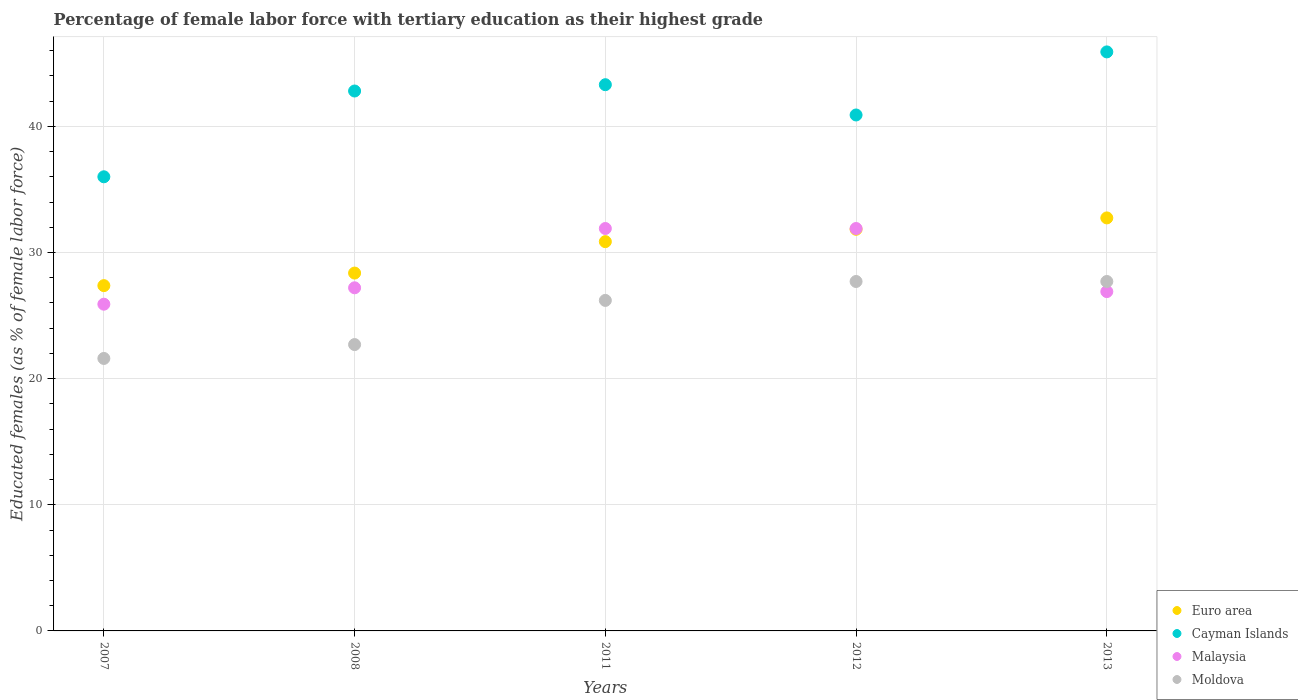How many different coloured dotlines are there?
Offer a terse response. 4. What is the percentage of female labor force with tertiary education in Euro area in 2013?
Your answer should be very brief. 32.74. Across all years, what is the maximum percentage of female labor force with tertiary education in Malaysia?
Your response must be concise. 31.9. Across all years, what is the minimum percentage of female labor force with tertiary education in Euro area?
Your response must be concise. 27.37. In which year was the percentage of female labor force with tertiary education in Euro area minimum?
Offer a terse response. 2007. What is the total percentage of female labor force with tertiary education in Moldova in the graph?
Provide a succinct answer. 125.9. What is the difference between the percentage of female labor force with tertiary education in Euro area in 2008 and that in 2013?
Your answer should be very brief. -4.37. What is the difference between the percentage of female labor force with tertiary education in Malaysia in 2011 and the percentage of female labor force with tertiary education in Euro area in 2008?
Offer a terse response. 3.53. What is the average percentage of female labor force with tertiary education in Cayman Islands per year?
Offer a terse response. 41.78. In the year 2013, what is the difference between the percentage of female labor force with tertiary education in Euro area and percentage of female labor force with tertiary education in Malaysia?
Keep it short and to the point. 5.84. What is the ratio of the percentage of female labor force with tertiary education in Moldova in 2007 to that in 2012?
Ensure brevity in your answer.  0.78. Is the difference between the percentage of female labor force with tertiary education in Euro area in 2007 and 2011 greater than the difference between the percentage of female labor force with tertiary education in Malaysia in 2007 and 2011?
Provide a short and direct response. Yes. What is the difference between the highest and the second highest percentage of female labor force with tertiary education in Moldova?
Offer a very short reply. 0. What is the difference between the highest and the lowest percentage of female labor force with tertiary education in Moldova?
Offer a very short reply. 6.1. Is it the case that in every year, the sum of the percentage of female labor force with tertiary education in Euro area and percentage of female labor force with tertiary education in Malaysia  is greater than the sum of percentage of female labor force with tertiary education in Cayman Islands and percentage of female labor force with tertiary education in Moldova?
Give a very brief answer. No. Is it the case that in every year, the sum of the percentage of female labor force with tertiary education in Malaysia and percentage of female labor force with tertiary education in Moldova  is greater than the percentage of female labor force with tertiary education in Cayman Islands?
Offer a terse response. Yes. Is the percentage of female labor force with tertiary education in Cayman Islands strictly greater than the percentage of female labor force with tertiary education in Moldova over the years?
Your response must be concise. Yes. Is the percentage of female labor force with tertiary education in Moldova strictly less than the percentage of female labor force with tertiary education in Cayman Islands over the years?
Give a very brief answer. Yes. How many years are there in the graph?
Your response must be concise. 5. What is the difference between two consecutive major ticks on the Y-axis?
Offer a terse response. 10. Are the values on the major ticks of Y-axis written in scientific E-notation?
Give a very brief answer. No. Does the graph contain grids?
Provide a succinct answer. Yes. How many legend labels are there?
Offer a very short reply. 4. How are the legend labels stacked?
Keep it short and to the point. Vertical. What is the title of the graph?
Keep it short and to the point. Percentage of female labor force with tertiary education as their highest grade. Does "Iran" appear as one of the legend labels in the graph?
Give a very brief answer. No. What is the label or title of the X-axis?
Ensure brevity in your answer.  Years. What is the label or title of the Y-axis?
Offer a very short reply. Educated females (as % of female labor force). What is the Educated females (as % of female labor force) of Euro area in 2007?
Ensure brevity in your answer.  27.37. What is the Educated females (as % of female labor force) of Cayman Islands in 2007?
Your response must be concise. 36. What is the Educated females (as % of female labor force) in Malaysia in 2007?
Offer a very short reply. 25.9. What is the Educated females (as % of female labor force) in Moldova in 2007?
Keep it short and to the point. 21.6. What is the Educated females (as % of female labor force) in Euro area in 2008?
Your answer should be very brief. 28.37. What is the Educated females (as % of female labor force) in Cayman Islands in 2008?
Offer a terse response. 42.8. What is the Educated females (as % of female labor force) of Malaysia in 2008?
Provide a short and direct response. 27.2. What is the Educated females (as % of female labor force) in Moldova in 2008?
Make the answer very short. 22.7. What is the Educated females (as % of female labor force) of Euro area in 2011?
Give a very brief answer. 30.86. What is the Educated females (as % of female labor force) in Cayman Islands in 2011?
Ensure brevity in your answer.  43.3. What is the Educated females (as % of female labor force) of Malaysia in 2011?
Give a very brief answer. 31.9. What is the Educated females (as % of female labor force) in Moldova in 2011?
Keep it short and to the point. 26.2. What is the Educated females (as % of female labor force) in Euro area in 2012?
Your answer should be compact. 31.84. What is the Educated females (as % of female labor force) in Cayman Islands in 2012?
Make the answer very short. 40.9. What is the Educated females (as % of female labor force) in Malaysia in 2012?
Offer a terse response. 31.9. What is the Educated females (as % of female labor force) of Moldova in 2012?
Provide a succinct answer. 27.7. What is the Educated females (as % of female labor force) of Euro area in 2013?
Provide a short and direct response. 32.74. What is the Educated females (as % of female labor force) in Cayman Islands in 2013?
Provide a succinct answer. 45.9. What is the Educated females (as % of female labor force) of Malaysia in 2013?
Provide a short and direct response. 26.9. What is the Educated females (as % of female labor force) in Moldova in 2013?
Ensure brevity in your answer.  27.7. Across all years, what is the maximum Educated females (as % of female labor force) in Euro area?
Offer a terse response. 32.74. Across all years, what is the maximum Educated females (as % of female labor force) in Cayman Islands?
Provide a succinct answer. 45.9. Across all years, what is the maximum Educated females (as % of female labor force) of Malaysia?
Make the answer very short. 31.9. Across all years, what is the maximum Educated females (as % of female labor force) of Moldova?
Provide a short and direct response. 27.7. Across all years, what is the minimum Educated females (as % of female labor force) in Euro area?
Your answer should be very brief. 27.37. Across all years, what is the minimum Educated females (as % of female labor force) in Cayman Islands?
Give a very brief answer. 36. Across all years, what is the minimum Educated females (as % of female labor force) in Malaysia?
Your answer should be very brief. 25.9. Across all years, what is the minimum Educated females (as % of female labor force) of Moldova?
Provide a short and direct response. 21.6. What is the total Educated females (as % of female labor force) of Euro area in the graph?
Keep it short and to the point. 151.18. What is the total Educated females (as % of female labor force) of Cayman Islands in the graph?
Keep it short and to the point. 208.9. What is the total Educated females (as % of female labor force) of Malaysia in the graph?
Give a very brief answer. 143.8. What is the total Educated females (as % of female labor force) in Moldova in the graph?
Offer a terse response. 125.9. What is the difference between the Educated females (as % of female labor force) in Euro area in 2007 and that in 2008?
Provide a succinct answer. -1. What is the difference between the Educated females (as % of female labor force) of Malaysia in 2007 and that in 2008?
Your answer should be very brief. -1.3. What is the difference between the Educated females (as % of female labor force) in Euro area in 2007 and that in 2011?
Your answer should be very brief. -3.49. What is the difference between the Educated females (as % of female labor force) in Cayman Islands in 2007 and that in 2011?
Offer a terse response. -7.3. What is the difference between the Educated females (as % of female labor force) in Euro area in 2007 and that in 2012?
Offer a very short reply. -4.47. What is the difference between the Educated females (as % of female labor force) in Malaysia in 2007 and that in 2012?
Ensure brevity in your answer.  -6. What is the difference between the Educated females (as % of female labor force) of Moldova in 2007 and that in 2012?
Keep it short and to the point. -6.1. What is the difference between the Educated females (as % of female labor force) of Euro area in 2007 and that in 2013?
Keep it short and to the point. -5.37. What is the difference between the Educated females (as % of female labor force) in Cayman Islands in 2007 and that in 2013?
Your answer should be compact. -9.9. What is the difference between the Educated females (as % of female labor force) in Malaysia in 2007 and that in 2013?
Ensure brevity in your answer.  -1. What is the difference between the Educated females (as % of female labor force) in Moldova in 2007 and that in 2013?
Give a very brief answer. -6.1. What is the difference between the Educated females (as % of female labor force) in Euro area in 2008 and that in 2011?
Offer a terse response. -2.49. What is the difference between the Educated females (as % of female labor force) of Cayman Islands in 2008 and that in 2011?
Keep it short and to the point. -0.5. What is the difference between the Educated females (as % of female labor force) in Malaysia in 2008 and that in 2011?
Provide a succinct answer. -4.7. What is the difference between the Educated females (as % of female labor force) in Euro area in 2008 and that in 2012?
Keep it short and to the point. -3.47. What is the difference between the Educated females (as % of female labor force) of Cayman Islands in 2008 and that in 2012?
Your response must be concise. 1.9. What is the difference between the Educated females (as % of female labor force) of Malaysia in 2008 and that in 2012?
Keep it short and to the point. -4.7. What is the difference between the Educated females (as % of female labor force) of Moldova in 2008 and that in 2012?
Offer a terse response. -5. What is the difference between the Educated females (as % of female labor force) in Euro area in 2008 and that in 2013?
Your answer should be compact. -4.37. What is the difference between the Educated females (as % of female labor force) of Cayman Islands in 2008 and that in 2013?
Give a very brief answer. -3.1. What is the difference between the Educated females (as % of female labor force) in Malaysia in 2008 and that in 2013?
Your answer should be very brief. 0.3. What is the difference between the Educated females (as % of female labor force) in Euro area in 2011 and that in 2012?
Make the answer very short. -0.98. What is the difference between the Educated females (as % of female labor force) in Cayman Islands in 2011 and that in 2012?
Give a very brief answer. 2.4. What is the difference between the Educated females (as % of female labor force) in Moldova in 2011 and that in 2012?
Your response must be concise. -1.5. What is the difference between the Educated females (as % of female labor force) in Euro area in 2011 and that in 2013?
Give a very brief answer. -1.88. What is the difference between the Educated females (as % of female labor force) of Cayman Islands in 2011 and that in 2013?
Your answer should be compact. -2.6. What is the difference between the Educated females (as % of female labor force) in Malaysia in 2011 and that in 2013?
Make the answer very short. 5. What is the difference between the Educated females (as % of female labor force) in Moldova in 2011 and that in 2013?
Your answer should be compact. -1.5. What is the difference between the Educated females (as % of female labor force) of Euro area in 2012 and that in 2013?
Make the answer very short. -0.9. What is the difference between the Educated females (as % of female labor force) in Malaysia in 2012 and that in 2013?
Offer a very short reply. 5. What is the difference between the Educated females (as % of female labor force) of Euro area in 2007 and the Educated females (as % of female labor force) of Cayman Islands in 2008?
Offer a terse response. -15.43. What is the difference between the Educated females (as % of female labor force) of Euro area in 2007 and the Educated females (as % of female labor force) of Malaysia in 2008?
Your response must be concise. 0.17. What is the difference between the Educated females (as % of female labor force) of Euro area in 2007 and the Educated females (as % of female labor force) of Moldova in 2008?
Offer a very short reply. 4.67. What is the difference between the Educated females (as % of female labor force) of Cayman Islands in 2007 and the Educated females (as % of female labor force) of Moldova in 2008?
Your answer should be compact. 13.3. What is the difference between the Educated females (as % of female labor force) of Euro area in 2007 and the Educated females (as % of female labor force) of Cayman Islands in 2011?
Give a very brief answer. -15.93. What is the difference between the Educated females (as % of female labor force) in Euro area in 2007 and the Educated females (as % of female labor force) in Malaysia in 2011?
Ensure brevity in your answer.  -4.53. What is the difference between the Educated females (as % of female labor force) of Euro area in 2007 and the Educated females (as % of female labor force) of Moldova in 2011?
Your response must be concise. 1.17. What is the difference between the Educated females (as % of female labor force) in Cayman Islands in 2007 and the Educated females (as % of female labor force) in Moldova in 2011?
Make the answer very short. 9.8. What is the difference between the Educated females (as % of female labor force) in Malaysia in 2007 and the Educated females (as % of female labor force) in Moldova in 2011?
Your response must be concise. -0.3. What is the difference between the Educated females (as % of female labor force) in Euro area in 2007 and the Educated females (as % of female labor force) in Cayman Islands in 2012?
Your response must be concise. -13.53. What is the difference between the Educated females (as % of female labor force) of Euro area in 2007 and the Educated females (as % of female labor force) of Malaysia in 2012?
Make the answer very short. -4.53. What is the difference between the Educated females (as % of female labor force) of Euro area in 2007 and the Educated females (as % of female labor force) of Moldova in 2012?
Make the answer very short. -0.33. What is the difference between the Educated females (as % of female labor force) in Malaysia in 2007 and the Educated females (as % of female labor force) in Moldova in 2012?
Your response must be concise. -1.8. What is the difference between the Educated females (as % of female labor force) of Euro area in 2007 and the Educated females (as % of female labor force) of Cayman Islands in 2013?
Keep it short and to the point. -18.53. What is the difference between the Educated females (as % of female labor force) of Euro area in 2007 and the Educated females (as % of female labor force) of Malaysia in 2013?
Make the answer very short. 0.47. What is the difference between the Educated females (as % of female labor force) of Euro area in 2007 and the Educated females (as % of female labor force) of Moldova in 2013?
Ensure brevity in your answer.  -0.33. What is the difference between the Educated females (as % of female labor force) in Cayman Islands in 2007 and the Educated females (as % of female labor force) in Malaysia in 2013?
Give a very brief answer. 9.1. What is the difference between the Educated females (as % of female labor force) in Euro area in 2008 and the Educated females (as % of female labor force) in Cayman Islands in 2011?
Keep it short and to the point. -14.93. What is the difference between the Educated females (as % of female labor force) in Euro area in 2008 and the Educated females (as % of female labor force) in Malaysia in 2011?
Your answer should be very brief. -3.53. What is the difference between the Educated females (as % of female labor force) in Euro area in 2008 and the Educated females (as % of female labor force) in Moldova in 2011?
Make the answer very short. 2.17. What is the difference between the Educated females (as % of female labor force) of Cayman Islands in 2008 and the Educated females (as % of female labor force) of Malaysia in 2011?
Your answer should be very brief. 10.9. What is the difference between the Educated females (as % of female labor force) of Euro area in 2008 and the Educated females (as % of female labor force) of Cayman Islands in 2012?
Provide a succinct answer. -12.53. What is the difference between the Educated females (as % of female labor force) in Euro area in 2008 and the Educated females (as % of female labor force) in Malaysia in 2012?
Offer a terse response. -3.53. What is the difference between the Educated females (as % of female labor force) in Euro area in 2008 and the Educated females (as % of female labor force) in Moldova in 2012?
Provide a short and direct response. 0.67. What is the difference between the Educated females (as % of female labor force) of Euro area in 2008 and the Educated females (as % of female labor force) of Cayman Islands in 2013?
Give a very brief answer. -17.53. What is the difference between the Educated females (as % of female labor force) of Euro area in 2008 and the Educated females (as % of female labor force) of Malaysia in 2013?
Provide a succinct answer. 1.47. What is the difference between the Educated females (as % of female labor force) in Euro area in 2008 and the Educated females (as % of female labor force) in Moldova in 2013?
Provide a short and direct response. 0.67. What is the difference between the Educated females (as % of female labor force) in Cayman Islands in 2008 and the Educated females (as % of female labor force) in Malaysia in 2013?
Give a very brief answer. 15.9. What is the difference between the Educated females (as % of female labor force) in Cayman Islands in 2008 and the Educated females (as % of female labor force) in Moldova in 2013?
Provide a short and direct response. 15.1. What is the difference between the Educated females (as % of female labor force) of Euro area in 2011 and the Educated females (as % of female labor force) of Cayman Islands in 2012?
Make the answer very short. -10.04. What is the difference between the Educated females (as % of female labor force) in Euro area in 2011 and the Educated females (as % of female labor force) in Malaysia in 2012?
Keep it short and to the point. -1.04. What is the difference between the Educated females (as % of female labor force) in Euro area in 2011 and the Educated females (as % of female labor force) in Moldova in 2012?
Give a very brief answer. 3.16. What is the difference between the Educated females (as % of female labor force) of Euro area in 2011 and the Educated females (as % of female labor force) of Cayman Islands in 2013?
Your response must be concise. -15.04. What is the difference between the Educated females (as % of female labor force) in Euro area in 2011 and the Educated females (as % of female labor force) in Malaysia in 2013?
Your answer should be compact. 3.96. What is the difference between the Educated females (as % of female labor force) of Euro area in 2011 and the Educated females (as % of female labor force) of Moldova in 2013?
Ensure brevity in your answer.  3.16. What is the difference between the Educated females (as % of female labor force) of Malaysia in 2011 and the Educated females (as % of female labor force) of Moldova in 2013?
Ensure brevity in your answer.  4.2. What is the difference between the Educated females (as % of female labor force) in Euro area in 2012 and the Educated females (as % of female labor force) in Cayman Islands in 2013?
Offer a terse response. -14.06. What is the difference between the Educated females (as % of female labor force) of Euro area in 2012 and the Educated females (as % of female labor force) of Malaysia in 2013?
Ensure brevity in your answer.  4.94. What is the difference between the Educated females (as % of female labor force) of Euro area in 2012 and the Educated females (as % of female labor force) of Moldova in 2013?
Your answer should be very brief. 4.14. What is the difference between the Educated females (as % of female labor force) of Cayman Islands in 2012 and the Educated females (as % of female labor force) of Malaysia in 2013?
Keep it short and to the point. 14. What is the difference between the Educated females (as % of female labor force) of Cayman Islands in 2012 and the Educated females (as % of female labor force) of Moldova in 2013?
Give a very brief answer. 13.2. What is the difference between the Educated females (as % of female labor force) in Malaysia in 2012 and the Educated females (as % of female labor force) in Moldova in 2013?
Provide a short and direct response. 4.2. What is the average Educated females (as % of female labor force) in Euro area per year?
Your answer should be very brief. 30.24. What is the average Educated females (as % of female labor force) in Cayman Islands per year?
Your response must be concise. 41.78. What is the average Educated females (as % of female labor force) of Malaysia per year?
Offer a terse response. 28.76. What is the average Educated females (as % of female labor force) of Moldova per year?
Your answer should be very brief. 25.18. In the year 2007, what is the difference between the Educated females (as % of female labor force) in Euro area and Educated females (as % of female labor force) in Cayman Islands?
Keep it short and to the point. -8.63. In the year 2007, what is the difference between the Educated females (as % of female labor force) of Euro area and Educated females (as % of female labor force) of Malaysia?
Give a very brief answer. 1.47. In the year 2007, what is the difference between the Educated females (as % of female labor force) of Euro area and Educated females (as % of female labor force) of Moldova?
Give a very brief answer. 5.77. In the year 2007, what is the difference between the Educated females (as % of female labor force) of Cayman Islands and Educated females (as % of female labor force) of Moldova?
Make the answer very short. 14.4. In the year 2007, what is the difference between the Educated females (as % of female labor force) in Malaysia and Educated females (as % of female labor force) in Moldova?
Make the answer very short. 4.3. In the year 2008, what is the difference between the Educated females (as % of female labor force) in Euro area and Educated females (as % of female labor force) in Cayman Islands?
Offer a terse response. -14.43. In the year 2008, what is the difference between the Educated females (as % of female labor force) of Euro area and Educated females (as % of female labor force) of Malaysia?
Offer a terse response. 1.17. In the year 2008, what is the difference between the Educated females (as % of female labor force) of Euro area and Educated females (as % of female labor force) of Moldova?
Your answer should be compact. 5.67. In the year 2008, what is the difference between the Educated females (as % of female labor force) in Cayman Islands and Educated females (as % of female labor force) in Malaysia?
Your answer should be very brief. 15.6. In the year 2008, what is the difference between the Educated females (as % of female labor force) of Cayman Islands and Educated females (as % of female labor force) of Moldova?
Your response must be concise. 20.1. In the year 2008, what is the difference between the Educated females (as % of female labor force) of Malaysia and Educated females (as % of female labor force) of Moldova?
Provide a short and direct response. 4.5. In the year 2011, what is the difference between the Educated females (as % of female labor force) of Euro area and Educated females (as % of female labor force) of Cayman Islands?
Give a very brief answer. -12.44. In the year 2011, what is the difference between the Educated females (as % of female labor force) in Euro area and Educated females (as % of female labor force) in Malaysia?
Ensure brevity in your answer.  -1.04. In the year 2011, what is the difference between the Educated females (as % of female labor force) in Euro area and Educated females (as % of female labor force) in Moldova?
Make the answer very short. 4.66. In the year 2012, what is the difference between the Educated females (as % of female labor force) of Euro area and Educated females (as % of female labor force) of Cayman Islands?
Your answer should be very brief. -9.06. In the year 2012, what is the difference between the Educated females (as % of female labor force) of Euro area and Educated females (as % of female labor force) of Malaysia?
Give a very brief answer. -0.06. In the year 2012, what is the difference between the Educated females (as % of female labor force) in Euro area and Educated females (as % of female labor force) in Moldova?
Provide a succinct answer. 4.14. In the year 2012, what is the difference between the Educated females (as % of female labor force) in Cayman Islands and Educated females (as % of female labor force) in Malaysia?
Your response must be concise. 9. In the year 2012, what is the difference between the Educated females (as % of female labor force) in Cayman Islands and Educated females (as % of female labor force) in Moldova?
Your answer should be compact. 13.2. In the year 2012, what is the difference between the Educated females (as % of female labor force) of Malaysia and Educated females (as % of female labor force) of Moldova?
Make the answer very short. 4.2. In the year 2013, what is the difference between the Educated females (as % of female labor force) of Euro area and Educated females (as % of female labor force) of Cayman Islands?
Give a very brief answer. -13.16. In the year 2013, what is the difference between the Educated females (as % of female labor force) of Euro area and Educated females (as % of female labor force) of Malaysia?
Keep it short and to the point. 5.84. In the year 2013, what is the difference between the Educated females (as % of female labor force) in Euro area and Educated females (as % of female labor force) in Moldova?
Offer a terse response. 5.04. What is the ratio of the Educated females (as % of female labor force) of Euro area in 2007 to that in 2008?
Your response must be concise. 0.96. What is the ratio of the Educated females (as % of female labor force) of Cayman Islands in 2007 to that in 2008?
Keep it short and to the point. 0.84. What is the ratio of the Educated females (as % of female labor force) in Malaysia in 2007 to that in 2008?
Provide a succinct answer. 0.95. What is the ratio of the Educated females (as % of female labor force) of Moldova in 2007 to that in 2008?
Offer a very short reply. 0.95. What is the ratio of the Educated females (as % of female labor force) of Euro area in 2007 to that in 2011?
Keep it short and to the point. 0.89. What is the ratio of the Educated females (as % of female labor force) in Cayman Islands in 2007 to that in 2011?
Keep it short and to the point. 0.83. What is the ratio of the Educated females (as % of female labor force) in Malaysia in 2007 to that in 2011?
Keep it short and to the point. 0.81. What is the ratio of the Educated females (as % of female labor force) in Moldova in 2007 to that in 2011?
Ensure brevity in your answer.  0.82. What is the ratio of the Educated females (as % of female labor force) of Euro area in 2007 to that in 2012?
Your response must be concise. 0.86. What is the ratio of the Educated females (as % of female labor force) in Cayman Islands in 2007 to that in 2012?
Offer a terse response. 0.88. What is the ratio of the Educated females (as % of female labor force) of Malaysia in 2007 to that in 2012?
Your response must be concise. 0.81. What is the ratio of the Educated females (as % of female labor force) of Moldova in 2007 to that in 2012?
Offer a very short reply. 0.78. What is the ratio of the Educated females (as % of female labor force) in Euro area in 2007 to that in 2013?
Provide a short and direct response. 0.84. What is the ratio of the Educated females (as % of female labor force) of Cayman Islands in 2007 to that in 2013?
Ensure brevity in your answer.  0.78. What is the ratio of the Educated females (as % of female labor force) of Malaysia in 2007 to that in 2013?
Provide a succinct answer. 0.96. What is the ratio of the Educated females (as % of female labor force) of Moldova in 2007 to that in 2013?
Make the answer very short. 0.78. What is the ratio of the Educated females (as % of female labor force) in Euro area in 2008 to that in 2011?
Provide a succinct answer. 0.92. What is the ratio of the Educated females (as % of female labor force) of Malaysia in 2008 to that in 2011?
Your answer should be very brief. 0.85. What is the ratio of the Educated females (as % of female labor force) of Moldova in 2008 to that in 2011?
Provide a short and direct response. 0.87. What is the ratio of the Educated females (as % of female labor force) in Euro area in 2008 to that in 2012?
Provide a short and direct response. 0.89. What is the ratio of the Educated females (as % of female labor force) in Cayman Islands in 2008 to that in 2012?
Provide a short and direct response. 1.05. What is the ratio of the Educated females (as % of female labor force) in Malaysia in 2008 to that in 2012?
Give a very brief answer. 0.85. What is the ratio of the Educated females (as % of female labor force) of Moldova in 2008 to that in 2012?
Your answer should be very brief. 0.82. What is the ratio of the Educated females (as % of female labor force) of Euro area in 2008 to that in 2013?
Ensure brevity in your answer.  0.87. What is the ratio of the Educated females (as % of female labor force) of Cayman Islands in 2008 to that in 2013?
Ensure brevity in your answer.  0.93. What is the ratio of the Educated females (as % of female labor force) of Malaysia in 2008 to that in 2013?
Your response must be concise. 1.01. What is the ratio of the Educated females (as % of female labor force) in Moldova in 2008 to that in 2013?
Your answer should be compact. 0.82. What is the ratio of the Educated females (as % of female labor force) of Euro area in 2011 to that in 2012?
Your response must be concise. 0.97. What is the ratio of the Educated females (as % of female labor force) of Cayman Islands in 2011 to that in 2012?
Give a very brief answer. 1.06. What is the ratio of the Educated females (as % of female labor force) of Moldova in 2011 to that in 2012?
Provide a short and direct response. 0.95. What is the ratio of the Educated females (as % of female labor force) of Euro area in 2011 to that in 2013?
Offer a very short reply. 0.94. What is the ratio of the Educated females (as % of female labor force) in Cayman Islands in 2011 to that in 2013?
Provide a short and direct response. 0.94. What is the ratio of the Educated females (as % of female labor force) of Malaysia in 2011 to that in 2013?
Provide a succinct answer. 1.19. What is the ratio of the Educated females (as % of female labor force) in Moldova in 2011 to that in 2013?
Offer a terse response. 0.95. What is the ratio of the Educated females (as % of female labor force) in Euro area in 2012 to that in 2013?
Offer a terse response. 0.97. What is the ratio of the Educated females (as % of female labor force) of Cayman Islands in 2012 to that in 2013?
Provide a short and direct response. 0.89. What is the ratio of the Educated females (as % of female labor force) of Malaysia in 2012 to that in 2013?
Keep it short and to the point. 1.19. What is the ratio of the Educated females (as % of female labor force) of Moldova in 2012 to that in 2013?
Provide a succinct answer. 1. What is the difference between the highest and the second highest Educated females (as % of female labor force) in Euro area?
Your response must be concise. 0.9. What is the difference between the highest and the second highest Educated females (as % of female labor force) of Moldova?
Ensure brevity in your answer.  0. What is the difference between the highest and the lowest Educated females (as % of female labor force) of Euro area?
Keep it short and to the point. 5.37. What is the difference between the highest and the lowest Educated females (as % of female labor force) of Cayman Islands?
Your response must be concise. 9.9. 